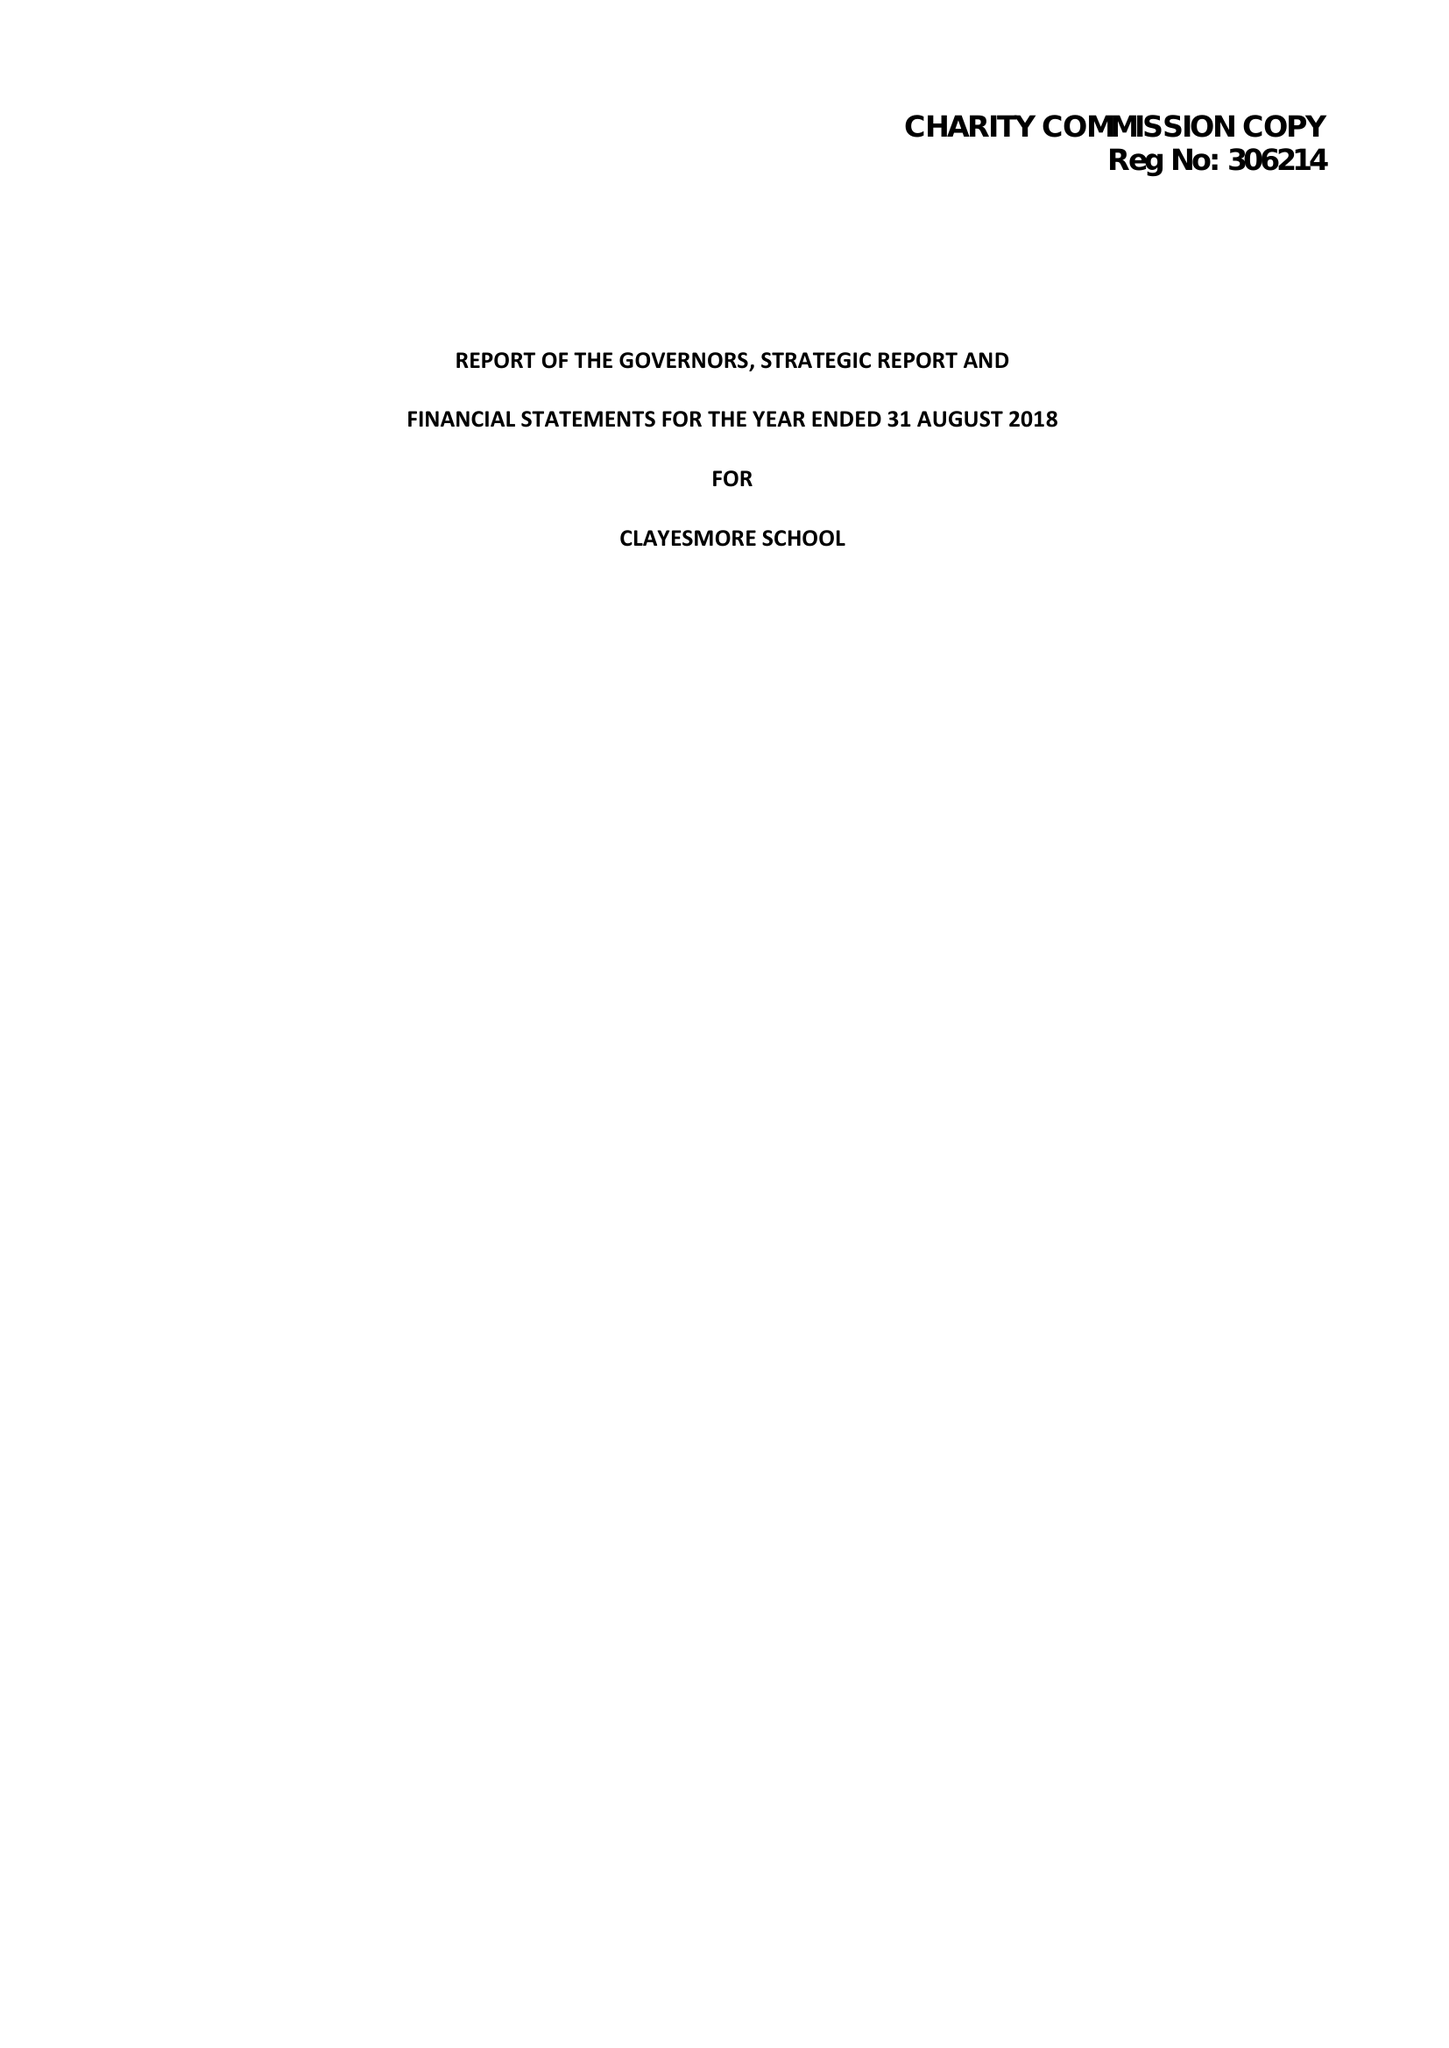What is the value for the report_date?
Answer the question using a single word or phrase. 2018-08-31 